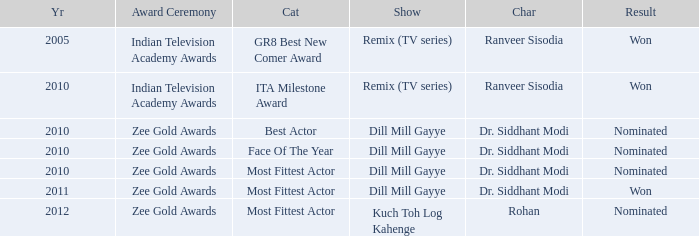Which show was nominated for the ITA Milestone Award at the Indian Television Academy Awards? Remix (TV series). 